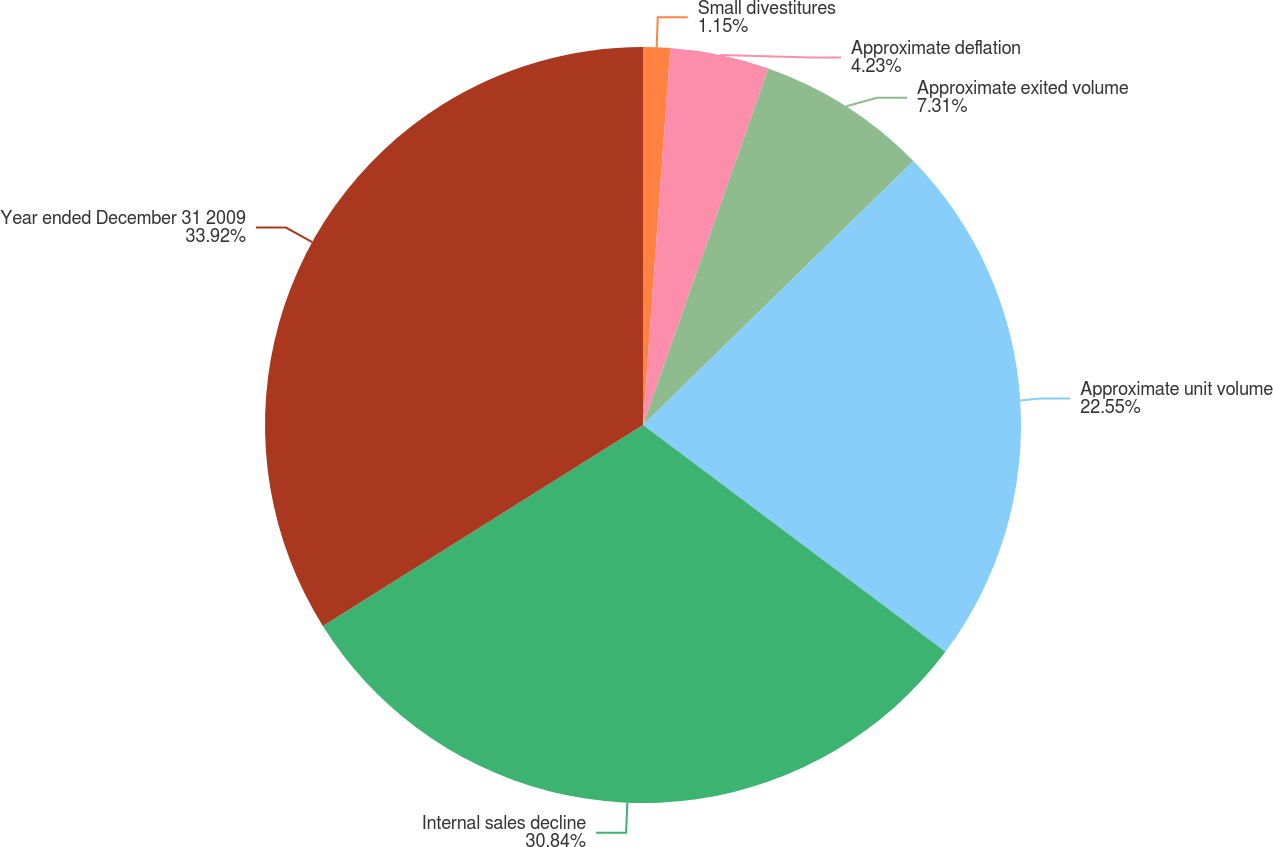<chart> <loc_0><loc_0><loc_500><loc_500><pie_chart><fcel>Small divestitures<fcel>Approximate deflation<fcel>Approximate exited volume<fcel>Approximate unit volume<fcel>Internal sales decline<fcel>Year ended December 31 2009<nl><fcel>1.15%<fcel>4.23%<fcel>7.31%<fcel>22.55%<fcel>30.84%<fcel>33.92%<nl></chart> 